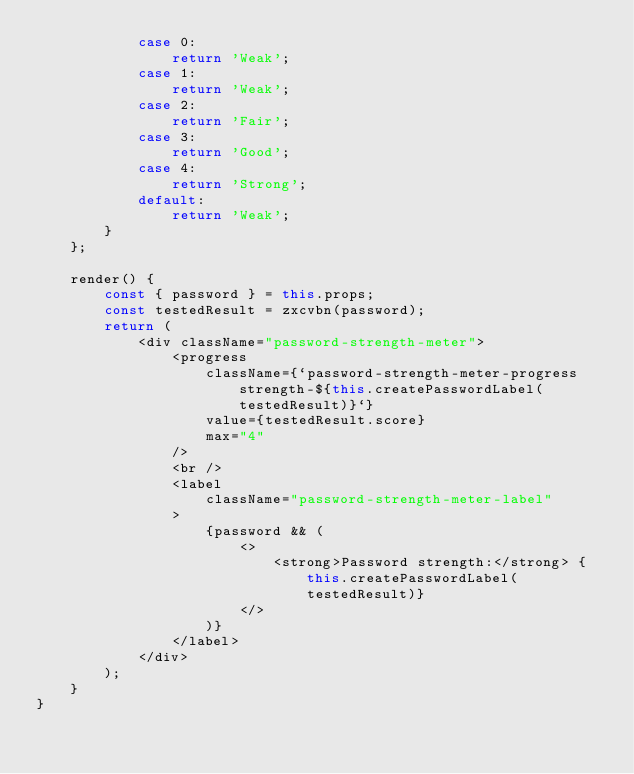<code> <loc_0><loc_0><loc_500><loc_500><_JavaScript_>            case 0:
                return 'Weak';
            case 1:
                return 'Weak';
            case 2:
                return 'Fair';
            case 3:
                return 'Good';
            case 4:
                return 'Strong';
            default:
                return 'Weak';
        }
    };

    render() {
        const { password } = this.props;
        const testedResult = zxcvbn(password);
        return (
            <div className="password-strength-meter">
                <progress
                    className={`password-strength-meter-progress strength-${this.createPasswordLabel(testedResult)}`}
                    value={testedResult.score}
                    max="4"
                />
                <br />
                <label
                    className="password-strength-meter-label"
                >
                    {password && (
                        <>
                            <strong>Password strength:</strong> {this.createPasswordLabel(testedResult)}
                        </>
                    )}
                </label>
            </div>
        );
    }
}</code> 